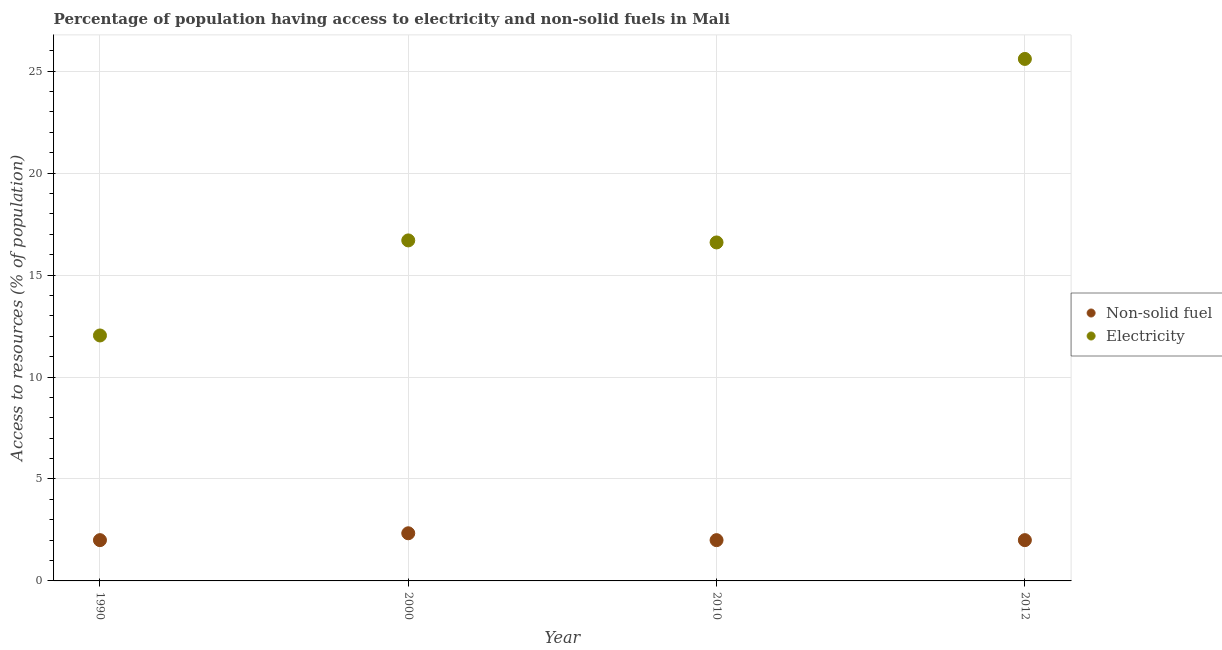How many different coloured dotlines are there?
Offer a terse response. 2. What is the percentage of population having access to electricity in 1990?
Give a very brief answer. 12.04. Across all years, what is the maximum percentage of population having access to electricity?
Give a very brief answer. 25.6. Across all years, what is the minimum percentage of population having access to non-solid fuel?
Provide a succinct answer. 2. In which year was the percentage of population having access to non-solid fuel minimum?
Provide a succinct answer. 1990. What is the total percentage of population having access to electricity in the graph?
Give a very brief answer. 70.94. What is the difference between the percentage of population having access to electricity in 1990 and that in 2010?
Provide a short and direct response. -4.56. What is the difference between the percentage of population having access to electricity in 2010 and the percentage of population having access to non-solid fuel in 1990?
Offer a very short reply. 14.6. What is the average percentage of population having access to electricity per year?
Provide a short and direct response. 17.73. In the year 2012, what is the difference between the percentage of population having access to electricity and percentage of population having access to non-solid fuel?
Your answer should be very brief. 23.6. What is the ratio of the percentage of population having access to electricity in 1990 to that in 2010?
Keep it short and to the point. 0.73. Is the percentage of population having access to electricity in 1990 less than that in 2000?
Provide a succinct answer. Yes. What is the difference between the highest and the second highest percentage of population having access to electricity?
Keep it short and to the point. 8.9. What is the difference between the highest and the lowest percentage of population having access to electricity?
Ensure brevity in your answer.  13.56. In how many years, is the percentage of population having access to electricity greater than the average percentage of population having access to electricity taken over all years?
Your response must be concise. 1. Does the percentage of population having access to non-solid fuel monotonically increase over the years?
Your answer should be very brief. No. Is the percentage of population having access to non-solid fuel strictly greater than the percentage of population having access to electricity over the years?
Give a very brief answer. No. Is the percentage of population having access to non-solid fuel strictly less than the percentage of population having access to electricity over the years?
Your answer should be compact. Yes. How many dotlines are there?
Keep it short and to the point. 2. How many years are there in the graph?
Provide a short and direct response. 4. Does the graph contain any zero values?
Offer a very short reply. No. Does the graph contain grids?
Your answer should be very brief. Yes. How many legend labels are there?
Offer a terse response. 2. What is the title of the graph?
Your answer should be compact. Percentage of population having access to electricity and non-solid fuels in Mali. What is the label or title of the X-axis?
Give a very brief answer. Year. What is the label or title of the Y-axis?
Offer a very short reply. Access to resources (% of population). What is the Access to resources (% of population) of Non-solid fuel in 1990?
Offer a terse response. 2. What is the Access to resources (% of population) of Electricity in 1990?
Make the answer very short. 12.04. What is the Access to resources (% of population) of Non-solid fuel in 2000?
Provide a succinct answer. 2.34. What is the Access to resources (% of population) in Electricity in 2000?
Give a very brief answer. 16.7. What is the Access to resources (% of population) of Non-solid fuel in 2010?
Your answer should be very brief. 2. What is the Access to resources (% of population) of Electricity in 2010?
Your answer should be very brief. 16.6. What is the Access to resources (% of population) of Non-solid fuel in 2012?
Your response must be concise. 2. What is the Access to resources (% of population) in Electricity in 2012?
Provide a short and direct response. 25.6. Across all years, what is the maximum Access to resources (% of population) in Non-solid fuel?
Provide a succinct answer. 2.34. Across all years, what is the maximum Access to resources (% of population) in Electricity?
Your answer should be compact. 25.6. Across all years, what is the minimum Access to resources (% of population) in Non-solid fuel?
Ensure brevity in your answer.  2. Across all years, what is the minimum Access to resources (% of population) in Electricity?
Your response must be concise. 12.04. What is the total Access to resources (% of population) of Non-solid fuel in the graph?
Your response must be concise. 8.34. What is the total Access to resources (% of population) of Electricity in the graph?
Offer a very short reply. 70.94. What is the difference between the Access to resources (% of population) in Non-solid fuel in 1990 and that in 2000?
Your answer should be very brief. -0.34. What is the difference between the Access to resources (% of population) in Electricity in 1990 and that in 2000?
Your answer should be very brief. -4.66. What is the difference between the Access to resources (% of population) of Non-solid fuel in 1990 and that in 2010?
Provide a succinct answer. 0. What is the difference between the Access to resources (% of population) in Electricity in 1990 and that in 2010?
Make the answer very short. -4.56. What is the difference between the Access to resources (% of population) in Electricity in 1990 and that in 2012?
Offer a very short reply. -13.56. What is the difference between the Access to resources (% of population) in Non-solid fuel in 2000 and that in 2010?
Your response must be concise. 0.34. What is the difference between the Access to resources (% of population) of Electricity in 2000 and that in 2010?
Keep it short and to the point. 0.1. What is the difference between the Access to resources (% of population) in Non-solid fuel in 2000 and that in 2012?
Make the answer very short. 0.34. What is the difference between the Access to resources (% of population) in Non-solid fuel in 1990 and the Access to resources (% of population) in Electricity in 2000?
Your response must be concise. -14.7. What is the difference between the Access to resources (% of population) in Non-solid fuel in 1990 and the Access to resources (% of population) in Electricity in 2010?
Offer a terse response. -14.6. What is the difference between the Access to resources (% of population) of Non-solid fuel in 1990 and the Access to resources (% of population) of Electricity in 2012?
Offer a very short reply. -23.6. What is the difference between the Access to resources (% of population) in Non-solid fuel in 2000 and the Access to resources (% of population) in Electricity in 2010?
Make the answer very short. -14.26. What is the difference between the Access to resources (% of population) in Non-solid fuel in 2000 and the Access to resources (% of population) in Electricity in 2012?
Offer a very short reply. -23.26. What is the difference between the Access to resources (% of population) of Non-solid fuel in 2010 and the Access to resources (% of population) of Electricity in 2012?
Give a very brief answer. -23.6. What is the average Access to resources (% of population) of Non-solid fuel per year?
Give a very brief answer. 2.08. What is the average Access to resources (% of population) in Electricity per year?
Your answer should be very brief. 17.73. In the year 1990, what is the difference between the Access to resources (% of population) of Non-solid fuel and Access to resources (% of population) of Electricity?
Your answer should be compact. -10.04. In the year 2000, what is the difference between the Access to resources (% of population) in Non-solid fuel and Access to resources (% of population) in Electricity?
Ensure brevity in your answer.  -14.36. In the year 2010, what is the difference between the Access to resources (% of population) in Non-solid fuel and Access to resources (% of population) in Electricity?
Your response must be concise. -14.6. In the year 2012, what is the difference between the Access to resources (% of population) of Non-solid fuel and Access to resources (% of population) of Electricity?
Your answer should be very brief. -23.6. What is the ratio of the Access to resources (% of population) in Non-solid fuel in 1990 to that in 2000?
Keep it short and to the point. 0.86. What is the ratio of the Access to resources (% of population) of Electricity in 1990 to that in 2000?
Your response must be concise. 0.72. What is the ratio of the Access to resources (% of population) in Electricity in 1990 to that in 2010?
Keep it short and to the point. 0.73. What is the ratio of the Access to resources (% of population) of Electricity in 1990 to that in 2012?
Your answer should be very brief. 0.47. What is the ratio of the Access to resources (% of population) in Non-solid fuel in 2000 to that in 2010?
Your answer should be very brief. 1.17. What is the ratio of the Access to resources (% of population) of Non-solid fuel in 2000 to that in 2012?
Your answer should be compact. 1.17. What is the ratio of the Access to resources (% of population) in Electricity in 2000 to that in 2012?
Offer a terse response. 0.65. What is the ratio of the Access to resources (% of population) of Electricity in 2010 to that in 2012?
Keep it short and to the point. 0.65. What is the difference between the highest and the second highest Access to resources (% of population) in Non-solid fuel?
Your answer should be very brief. 0.34. What is the difference between the highest and the second highest Access to resources (% of population) of Electricity?
Offer a very short reply. 8.9. What is the difference between the highest and the lowest Access to resources (% of population) of Non-solid fuel?
Your answer should be very brief. 0.34. What is the difference between the highest and the lowest Access to resources (% of population) of Electricity?
Offer a terse response. 13.56. 